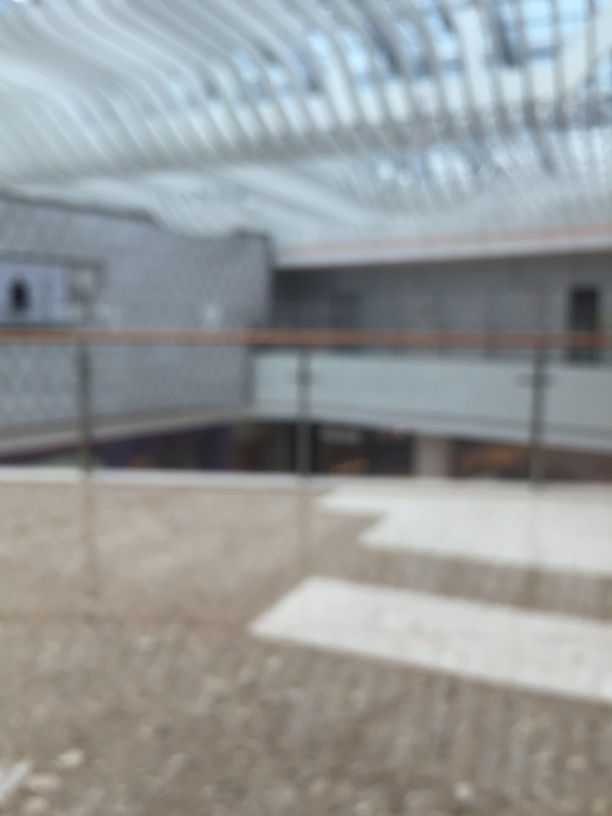What is the overall quality of this image? The overall quality of this image is poor (Option A). The image is significantly out of focus, which eliminates detail and clarity that are important for both aesthetics and functionality. A good quality image would have crisp details, proper exposure, and clear subject matter, which are lacking here. 